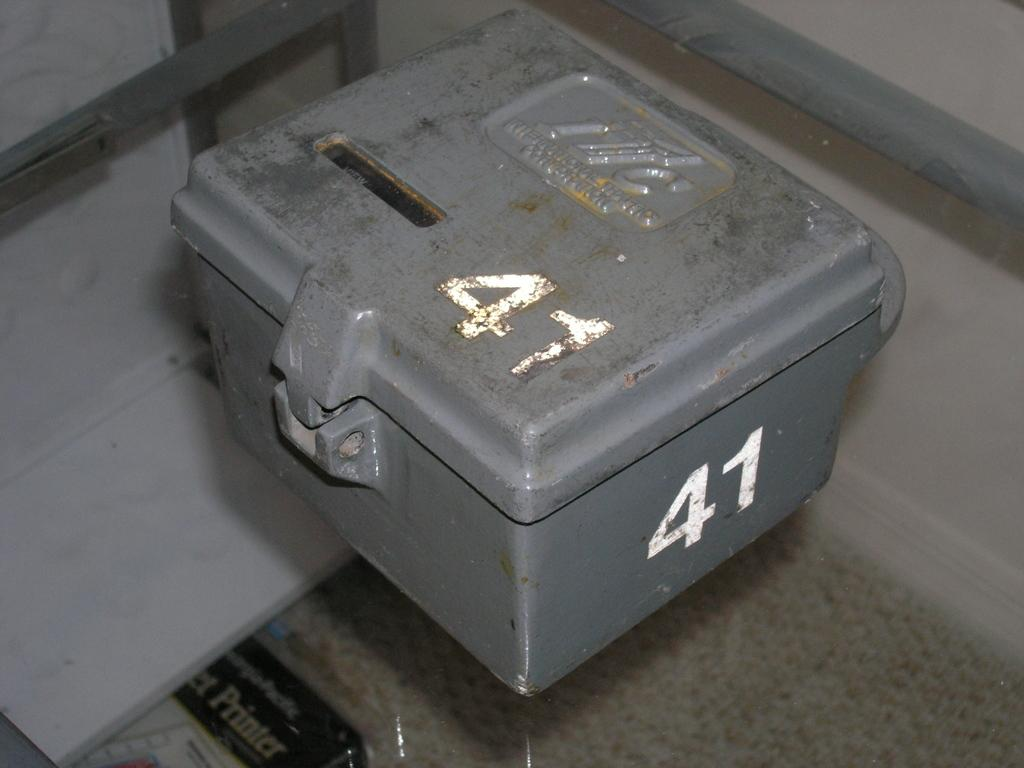Provide a one-sentence caption for the provided image. The steel box number 41 is closed but not locked. 